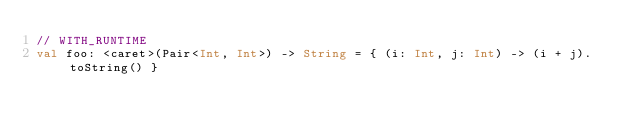<code> <loc_0><loc_0><loc_500><loc_500><_Kotlin_>// WITH_RUNTIME
val foo: <caret>(Pair<Int, Int>) -> String = { (i: Int, j: Int) -> (i + j).toString() }</code> 